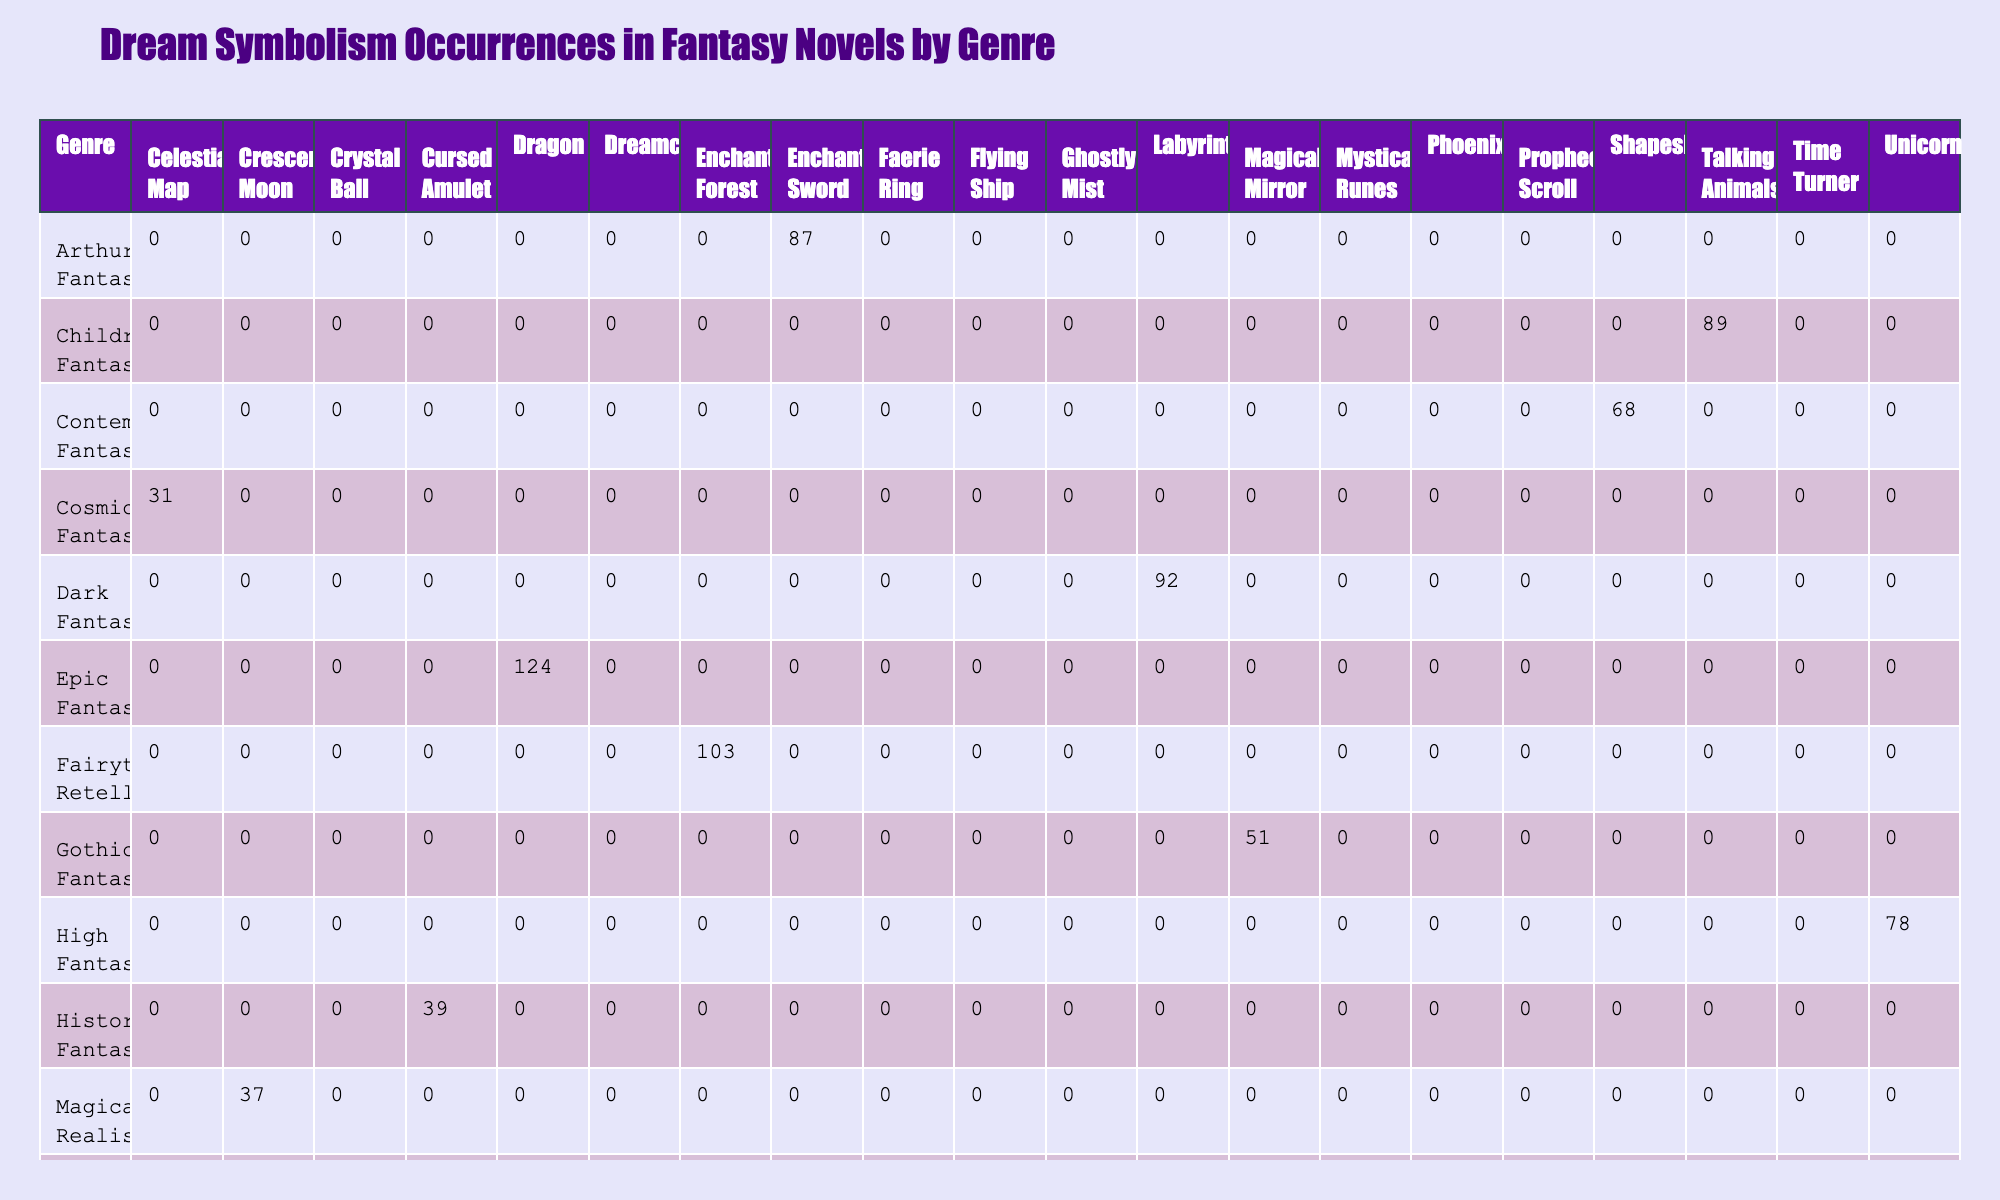What is the maximum number of occurrences for a dream symbol in the table? The maximum value in the occurrences column is found by scanning through the rows and identifying the highest individual occurrence. The maximum occurrence is for the "Dragon" symbol in "Epic Fantasy," which has 124 occurrences.
Answer: 124 Which genre has the least occurrences for dream symbolism? To find the genre with the least occurrences, we look for the row with the smallest sum in the occurrences column. The "Cosmic Fantasy" genre has the lowest occurrence at 31.
Answer: Cosmic Fantasy How many dream symbols appear in the Urban Fantasy genre? By counting the number of dream symbols present in the "Urban Fantasy" row, we see there are 2 dream symbols: "Phoenix" and "Faerie Ring."
Answer: 2 What is the total number of occurrences for dream symbols in High Fantasy and Dark Fantasy combined? We need to sum the occurrences for the "High Fantasy" genre (78) and "Dark Fantasy" genre (92). The total is 78 + 92 = 170.
Answer: 170 Is "Time Turner" a dream symbol associated with Dark Fantasy? To answer this, we check the entry for "Time Turner" and find it under "Portal Fantasy," not "Dark Fantasy," so the statement is false.
Answer: No 